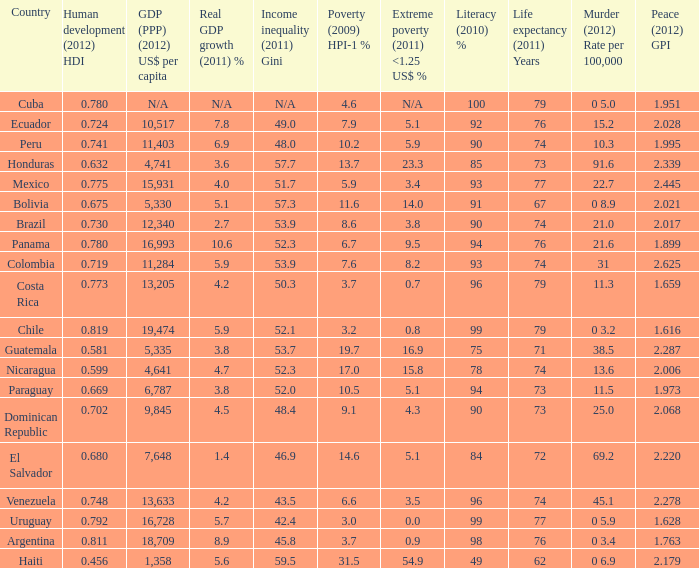What is the sum of poverty (2009) HPI-1 % when the GDP (PPP) (2012) US$ per capita of 11,284? 1.0. 